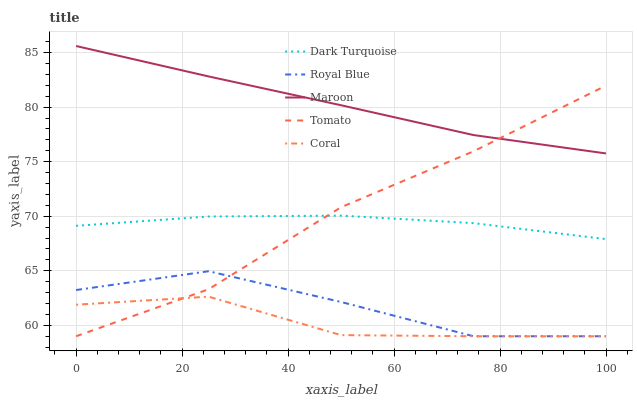Does Coral have the minimum area under the curve?
Answer yes or no. Yes. Does Maroon have the maximum area under the curve?
Answer yes or no. Yes. Does Dark Turquoise have the minimum area under the curve?
Answer yes or no. No. Does Dark Turquoise have the maximum area under the curve?
Answer yes or no. No. Is Maroon the smoothest?
Answer yes or no. Yes. Is Royal Blue the roughest?
Answer yes or no. Yes. Is Dark Turquoise the smoothest?
Answer yes or no. No. Is Dark Turquoise the roughest?
Answer yes or no. No. Does Tomato have the lowest value?
Answer yes or no. Yes. Does Dark Turquoise have the lowest value?
Answer yes or no. No. Does Maroon have the highest value?
Answer yes or no. Yes. Does Dark Turquoise have the highest value?
Answer yes or no. No. Is Coral less than Maroon?
Answer yes or no. Yes. Is Maroon greater than Dark Turquoise?
Answer yes or no. Yes. Does Coral intersect Royal Blue?
Answer yes or no. Yes. Is Coral less than Royal Blue?
Answer yes or no. No. Is Coral greater than Royal Blue?
Answer yes or no. No. Does Coral intersect Maroon?
Answer yes or no. No. 